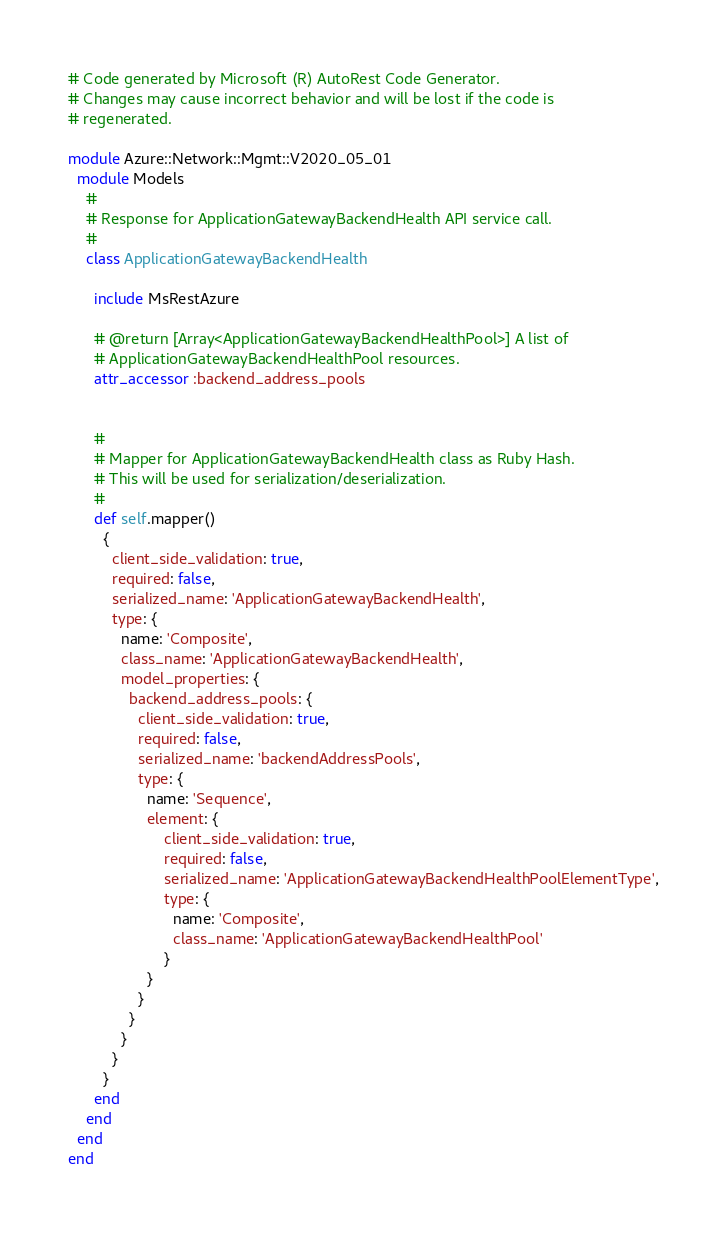<code> <loc_0><loc_0><loc_500><loc_500><_Ruby_># Code generated by Microsoft (R) AutoRest Code Generator.
# Changes may cause incorrect behavior and will be lost if the code is
# regenerated.

module Azure::Network::Mgmt::V2020_05_01
  module Models
    #
    # Response for ApplicationGatewayBackendHealth API service call.
    #
    class ApplicationGatewayBackendHealth

      include MsRestAzure

      # @return [Array<ApplicationGatewayBackendHealthPool>] A list of
      # ApplicationGatewayBackendHealthPool resources.
      attr_accessor :backend_address_pools


      #
      # Mapper for ApplicationGatewayBackendHealth class as Ruby Hash.
      # This will be used for serialization/deserialization.
      #
      def self.mapper()
        {
          client_side_validation: true,
          required: false,
          serialized_name: 'ApplicationGatewayBackendHealth',
          type: {
            name: 'Composite',
            class_name: 'ApplicationGatewayBackendHealth',
            model_properties: {
              backend_address_pools: {
                client_side_validation: true,
                required: false,
                serialized_name: 'backendAddressPools',
                type: {
                  name: 'Sequence',
                  element: {
                      client_side_validation: true,
                      required: false,
                      serialized_name: 'ApplicationGatewayBackendHealthPoolElementType',
                      type: {
                        name: 'Composite',
                        class_name: 'ApplicationGatewayBackendHealthPool'
                      }
                  }
                }
              }
            }
          }
        }
      end
    end
  end
end
</code> 